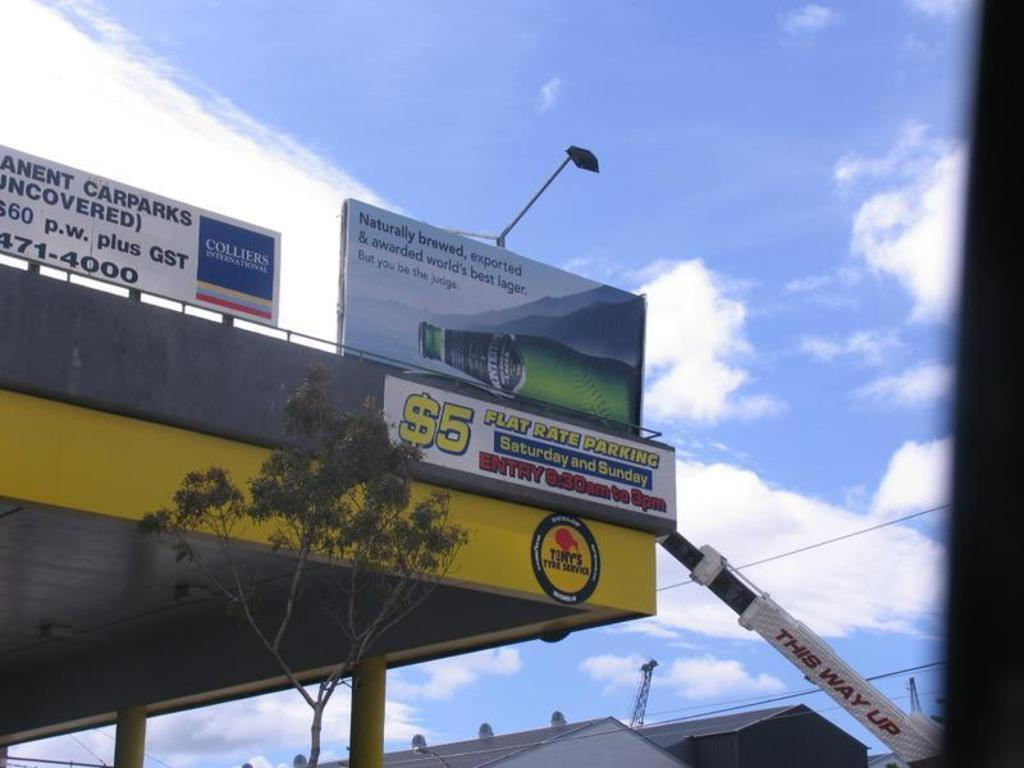<image>
Relay a brief, clear account of the picture shown. Parking for a $5 flat rate parking on Saturday and Sunday 